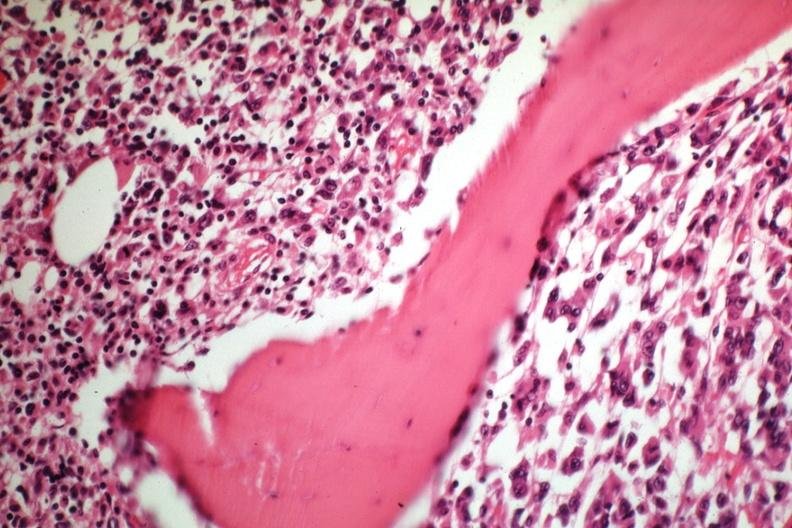does sickle cell disease show tumor well shown gross is slide?
Answer the question using a single word or phrase. No 